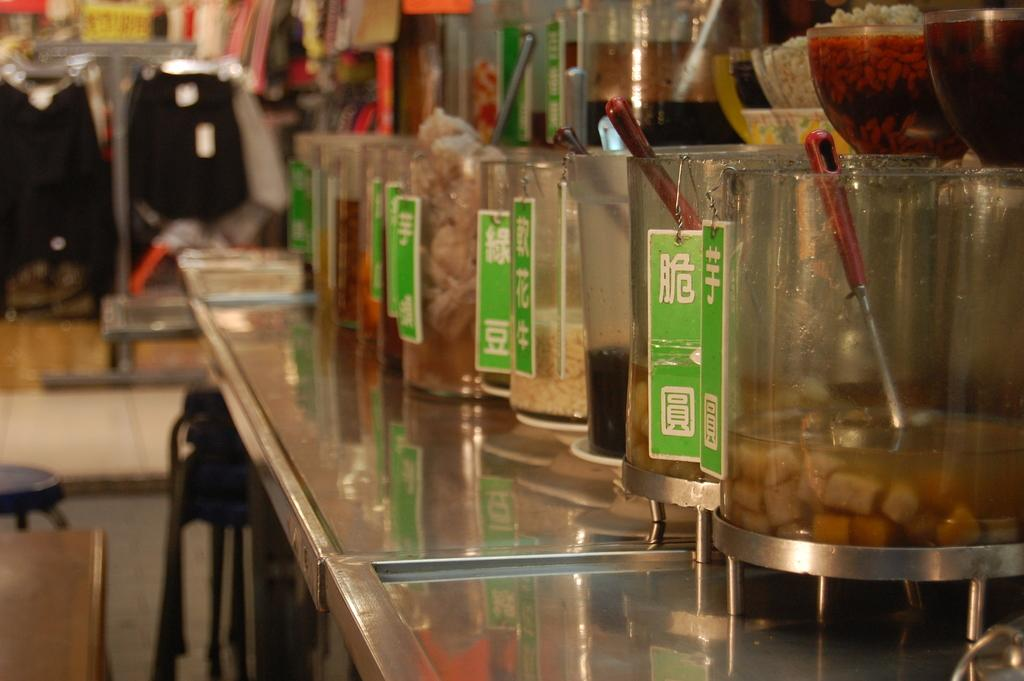What type of containers hold the food items in the image? There are bowls and glass items that hold the food items in the image. What utensils are present in the image? Spoons are present in the image. What type of seating can be seen in the background of the image? There are stools in the background of the image. What other items can be seen in the background of the image? There are other items visible in the background, but their specific nature is not mentioned in the facts. How does the mind of the person in the image express anger? There is no person present in the image, and therefore no mind or expression of anger can be observed. 